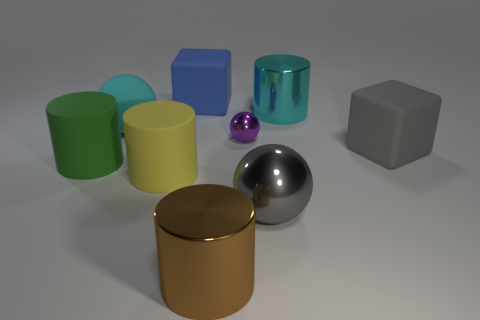Subtract all large brown shiny cylinders. How many cylinders are left? 3 Subtract all green cylinders. How many cylinders are left? 3 Subtract all blocks. How many objects are left? 7 Subtract 2 cylinders. How many cylinders are left? 2 Add 1 small metal objects. How many objects exist? 10 Subtract all purple blocks. How many green cylinders are left? 1 Add 3 large gray metallic objects. How many large gray metallic objects are left? 4 Add 1 big blue balls. How many big blue balls exist? 1 Subtract 1 cyan balls. How many objects are left? 8 Subtract all blue cubes. Subtract all green balls. How many cubes are left? 1 